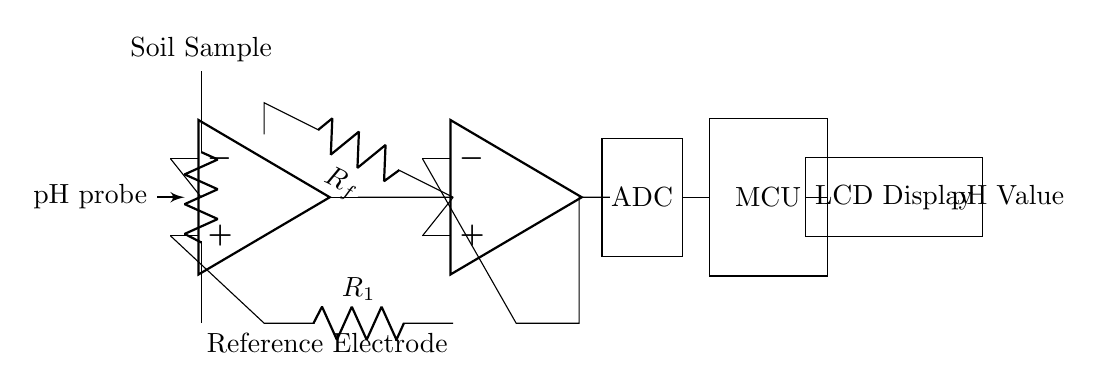What component is used to measure pH? The circuit includes a pH probe, which is the primary component for measuring pH levels in the soil sample.
Answer: pH probe What type of operational amplifier is used in this circuit? The circuit employs two operational amplifiers: one for amplifying the pH signal and another as a buffer.
Answer: Two What does the ADC do in this circuit? The ADC converts the analog output from the buffer into a digital signal for the microcontroller to process.
Answer: Converts analog to digital What is the purpose of the microcontroller in this setup? The microcontroller processes the digital signal from the ADC and manages the overall functioning of the pH meter, including displaying the result.
Answer: Processing data Which component is responsible for displaying the pH value? The LCD Display shows the pH value as output for the user to read.
Answer: LCD Display How many resistors are used in the amplifier section? There are two resistors indicated in the diagram: R1 and Rf, used in conjunction with the op-amp for signal amplification.
Answer: Two What does the reference electrode represent in the circuit? The reference electrode serves as a stable reference point for measuring the pH level relative to the pH probe's output.
Answer: Stable reference 